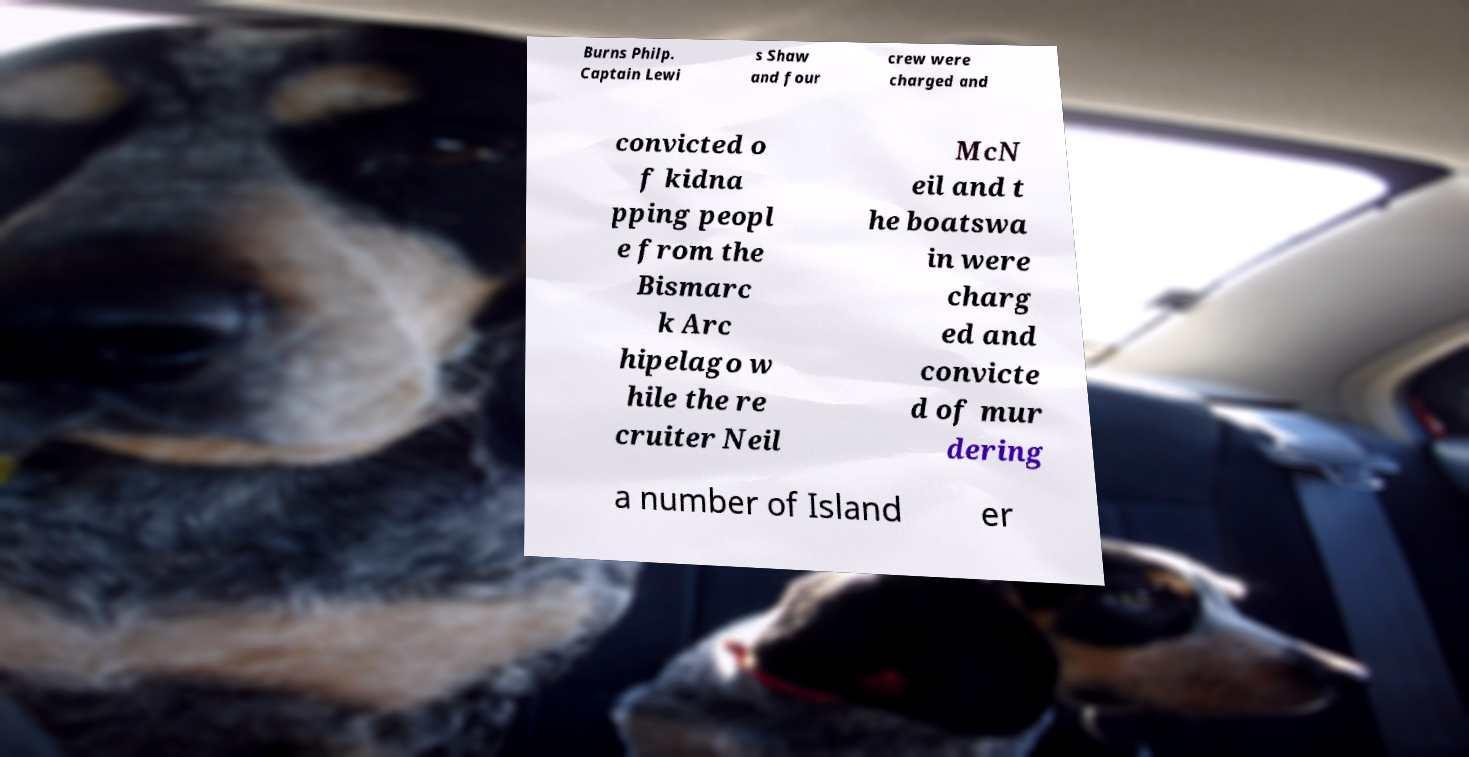What messages or text are displayed in this image? I need them in a readable, typed format. Burns Philp. Captain Lewi s Shaw and four crew were charged and convicted o f kidna pping peopl e from the Bismarc k Arc hipelago w hile the re cruiter Neil McN eil and t he boatswa in were charg ed and convicte d of mur dering a number of Island er 